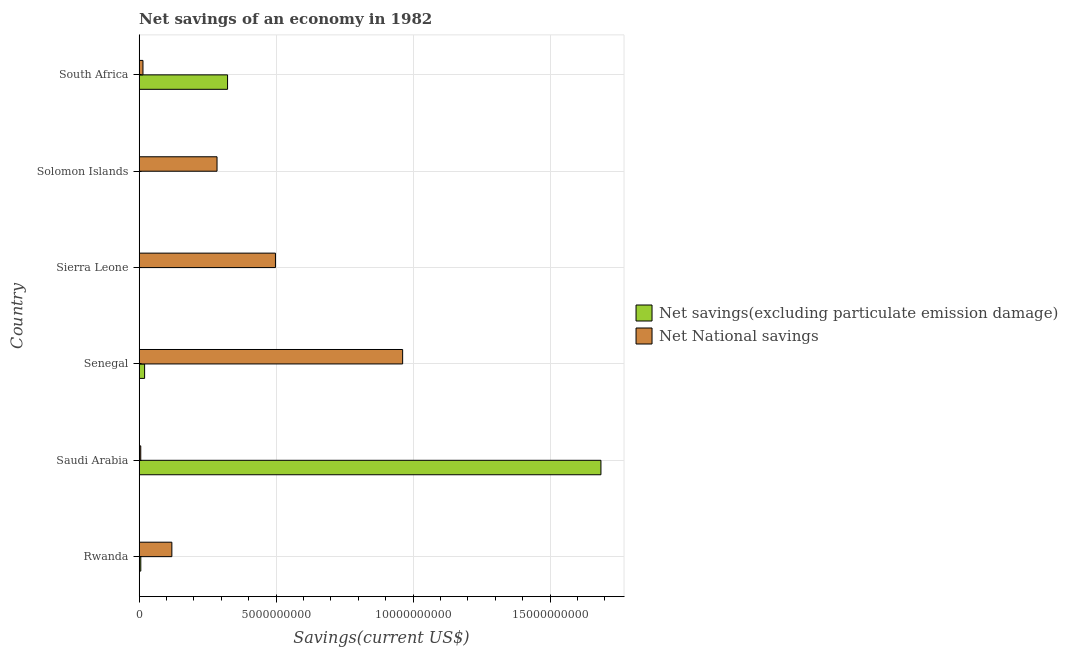Are the number of bars per tick equal to the number of legend labels?
Provide a succinct answer. No. How many bars are there on the 2nd tick from the top?
Give a very brief answer. 1. What is the label of the 3rd group of bars from the top?
Your answer should be very brief. Sierra Leone. In how many cases, is the number of bars for a given country not equal to the number of legend labels?
Make the answer very short. 2. Across all countries, what is the maximum net national savings?
Give a very brief answer. 9.62e+09. Across all countries, what is the minimum net savings(excluding particulate emission damage)?
Your response must be concise. 0. In which country was the net national savings maximum?
Offer a terse response. Senegal. What is the total net national savings in the graph?
Ensure brevity in your answer.  1.88e+1. What is the difference between the net national savings in Rwanda and that in Solomon Islands?
Offer a very short reply. -1.65e+09. What is the difference between the net national savings in Solomon Islands and the net savings(excluding particulate emission damage) in Senegal?
Keep it short and to the point. 2.64e+09. What is the average net savings(excluding particulate emission damage) per country?
Provide a succinct answer. 3.39e+09. What is the difference between the net national savings and net savings(excluding particulate emission damage) in South Africa?
Your response must be concise. -3.09e+09. What is the ratio of the net national savings in Saudi Arabia to that in Senegal?
Your answer should be compact. 0.01. Is the difference between the net savings(excluding particulate emission damage) in Rwanda and Saudi Arabia greater than the difference between the net national savings in Rwanda and Saudi Arabia?
Provide a short and direct response. No. What is the difference between the highest and the second highest net savings(excluding particulate emission damage)?
Ensure brevity in your answer.  1.36e+1. What is the difference between the highest and the lowest net savings(excluding particulate emission damage)?
Your response must be concise. 1.69e+1. In how many countries, is the net savings(excluding particulate emission damage) greater than the average net savings(excluding particulate emission damage) taken over all countries?
Provide a succinct answer. 1. How many bars are there?
Offer a terse response. 10. What is the difference between two consecutive major ticks on the X-axis?
Provide a short and direct response. 5.00e+09. Are the values on the major ticks of X-axis written in scientific E-notation?
Ensure brevity in your answer.  No. Does the graph contain any zero values?
Your response must be concise. Yes. Does the graph contain grids?
Your answer should be compact. Yes. How are the legend labels stacked?
Provide a succinct answer. Vertical. What is the title of the graph?
Offer a terse response. Net savings of an economy in 1982. What is the label or title of the X-axis?
Ensure brevity in your answer.  Savings(current US$). What is the Savings(current US$) of Net savings(excluding particulate emission damage) in Rwanda?
Make the answer very short. 5.99e+07. What is the Savings(current US$) in Net National savings in Rwanda?
Ensure brevity in your answer.  1.19e+09. What is the Savings(current US$) of Net savings(excluding particulate emission damage) in Saudi Arabia?
Your answer should be very brief. 1.69e+1. What is the Savings(current US$) in Net National savings in Saudi Arabia?
Offer a very short reply. 5.80e+07. What is the Savings(current US$) in Net savings(excluding particulate emission damage) in Senegal?
Provide a succinct answer. 1.99e+08. What is the Savings(current US$) of Net National savings in Senegal?
Give a very brief answer. 9.62e+09. What is the Savings(current US$) in Net savings(excluding particulate emission damage) in Sierra Leone?
Your response must be concise. 0. What is the Savings(current US$) in Net National savings in Sierra Leone?
Ensure brevity in your answer.  4.98e+09. What is the Savings(current US$) in Net savings(excluding particulate emission damage) in Solomon Islands?
Provide a succinct answer. 0. What is the Savings(current US$) of Net National savings in Solomon Islands?
Make the answer very short. 2.84e+09. What is the Savings(current US$) in Net savings(excluding particulate emission damage) in South Africa?
Make the answer very short. 3.23e+09. What is the Savings(current US$) of Net National savings in South Africa?
Your answer should be compact. 1.39e+08. Across all countries, what is the maximum Savings(current US$) of Net savings(excluding particulate emission damage)?
Give a very brief answer. 1.69e+1. Across all countries, what is the maximum Savings(current US$) in Net National savings?
Give a very brief answer. 9.62e+09. Across all countries, what is the minimum Savings(current US$) in Net National savings?
Provide a short and direct response. 5.80e+07. What is the total Savings(current US$) in Net savings(excluding particulate emission damage) in the graph?
Provide a short and direct response. 2.03e+1. What is the total Savings(current US$) of Net National savings in the graph?
Offer a terse response. 1.88e+1. What is the difference between the Savings(current US$) of Net savings(excluding particulate emission damage) in Rwanda and that in Saudi Arabia?
Your answer should be compact. -1.68e+1. What is the difference between the Savings(current US$) in Net National savings in Rwanda and that in Saudi Arabia?
Give a very brief answer. 1.14e+09. What is the difference between the Savings(current US$) of Net savings(excluding particulate emission damage) in Rwanda and that in Senegal?
Your answer should be compact. -1.39e+08. What is the difference between the Savings(current US$) of Net National savings in Rwanda and that in Senegal?
Your response must be concise. -8.43e+09. What is the difference between the Savings(current US$) of Net National savings in Rwanda and that in Sierra Leone?
Make the answer very short. -3.78e+09. What is the difference between the Savings(current US$) in Net National savings in Rwanda and that in Solomon Islands?
Offer a very short reply. -1.65e+09. What is the difference between the Savings(current US$) in Net savings(excluding particulate emission damage) in Rwanda and that in South Africa?
Your response must be concise. -3.17e+09. What is the difference between the Savings(current US$) of Net National savings in Rwanda and that in South Africa?
Offer a terse response. 1.05e+09. What is the difference between the Savings(current US$) of Net savings(excluding particulate emission damage) in Saudi Arabia and that in Senegal?
Provide a short and direct response. 1.67e+1. What is the difference between the Savings(current US$) in Net National savings in Saudi Arabia and that in Senegal?
Ensure brevity in your answer.  -9.56e+09. What is the difference between the Savings(current US$) in Net National savings in Saudi Arabia and that in Sierra Leone?
Ensure brevity in your answer.  -4.92e+09. What is the difference between the Savings(current US$) of Net National savings in Saudi Arabia and that in Solomon Islands?
Your answer should be very brief. -2.78e+09. What is the difference between the Savings(current US$) in Net savings(excluding particulate emission damage) in Saudi Arabia and that in South Africa?
Offer a very short reply. 1.36e+1. What is the difference between the Savings(current US$) in Net National savings in Saudi Arabia and that in South Africa?
Your answer should be very brief. -8.08e+07. What is the difference between the Savings(current US$) of Net National savings in Senegal and that in Sierra Leone?
Provide a short and direct response. 4.64e+09. What is the difference between the Savings(current US$) of Net National savings in Senegal and that in Solomon Islands?
Your answer should be very brief. 6.78e+09. What is the difference between the Savings(current US$) of Net savings(excluding particulate emission damage) in Senegal and that in South Africa?
Keep it short and to the point. -3.03e+09. What is the difference between the Savings(current US$) of Net National savings in Senegal and that in South Africa?
Your answer should be very brief. 9.48e+09. What is the difference between the Savings(current US$) of Net National savings in Sierra Leone and that in Solomon Islands?
Your answer should be compact. 2.13e+09. What is the difference between the Savings(current US$) of Net National savings in Sierra Leone and that in South Africa?
Offer a very short reply. 4.84e+09. What is the difference between the Savings(current US$) of Net National savings in Solomon Islands and that in South Africa?
Provide a succinct answer. 2.70e+09. What is the difference between the Savings(current US$) in Net savings(excluding particulate emission damage) in Rwanda and the Savings(current US$) in Net National savings in Saudi Arabia?
Provide a succinct answer. 1.93e+06. What is the difference between the Savings(current US$) of Net savings(excluding particulate emission damage) in Rwanda and the Savings(current US$) of Net National savings in Senegal?
Provide a short and direct response. -9.56e+09. What is the difference between the Savings(current US$) in Net savings(excluding particulate emission damage) in Rwanda and the Savings(current US$) in Net National savings in Sierra Leone?
Offer a very short reply. -4.92e+09. What is the difference between the Savings(current US$) in Net savings(excluding particulate emission damage) in Rwanda and the Savings(current US$) in Net National savings in Solomon Islands?
Provide a short and direct response. -2.78e+09. What is the difference between the Savings(current US$) of Net savings(excluding particulate emission damage) in Rwanda and the Savings(current US$) of Net National savings in South Africa?
Provide a short and direct response. -7.88e+07. What is the difference between the Savings(current US$) of Net savings(excluding particulate emission damage) in Saudi Arabia and the Savings(current US$) of Net National savings in Senegal?
Offer a very short reply. 7.24e+09. What is the difference between the Savings(current US$) of Net savings(excluding particulate emission damage) in Saudi Arabia and the Savings(current US$) of Net National savings in Sierra Leone?
Offer a terse response. 1.19e+1. What is the difference between the Savings(current US$) of Net savings(excluding particulate emission damage) in Saudi Arabia and the Savings(current US$) of Net National savings in Solomon Islands?
Give a very brief answer. 1.40e+1. What is the difference between the Savings(current US$) in Net savings(excluding particulate emission damage) in Saudi Arabia and the Savings(current US$) in Net National savings in South Africa?
Give a very brief answer. 1.67e+1. What is the difference between the Savings(current US$) in Net savings(excluding particulate emission damage) in Senegal and the Savings(current US$) in Net National savings in Sierra Leone?
Your response must be concise. -4.78e+09. What is the difference between the Savings(current US$) of Net savings(excluding particulate emission damage) in Senegal and the Savings(current US$) of Net National savings in Solomon Islands?
Provide a short and direct response. -2.64e+09. What is the difference between the Savings(current US$) of Net savings(excluding particulate emission damage) in Senegal and the Savings(current US$) of Net National savings in South Africa?
Provide a short and direct response. 6.02e+07. What is the average Savings(current US$) of Net savings(excluding particulate emission damage) per country?
Offer a terse response. 3.39e+09. What is the average Savings(current US$) of Net National savings per country?
Keep it short and to the point. 3.14e+09. What is the difference between the Savings(current US$) in Net savings(excluding particulate emission damage) and Savings(current US$) in Net National savings in Rwanda?
Your answer should be very brief. -1.13e+09. What is the difference between the Savings(current US$) of Net savings(excluding particulate emission damage) and Savings(current US$) of Net National savings in Saudi Arabia?
Provide a short and direct response. 1.68e+1. What is the difference between the Savings(current US$) in Net savings(excluding particulate emission damage) and Savings(current US$) in Net National savings in Senegal?
Offer a terse response. -9.42e+09. What is the difference between the Savings(current US$) of Net savings(excluding particulate emission damage) and Savings(current US$) of Net National savings in South Africa?
Make the answer very short. 3.09e+09. What is the ratio of the Savings(current US$) in Net savings(excluding particulate emission damage) in Rwanda to that in Saudi Arabia?
Offer a terse response. 0. What is the ratio of the Savings(current US$) of Net National savings in Rwanda to that in Saudi Arabia?
Make the answer very short. 20.58. What is the ratio of the Savings(current US$) of Net savings(excluding particulate emission damage) in Rwanda to that in Senegal?
Your response must be concise. 0.3. What is the ratio of the Savings(current US$) in Net National savings in Rwanda to that in Senegal?
Give a very brief answer. 0.12. What is the ratio of the Savings(current US$) in Net National savings in Rwanda to that in Sierra Leone?
Provide a succinct answer. 0.24. What is the ratio of the Savings(current US$) of Net National savings in Rwanda to that in Solomon Islands?
Keep it short and to the point. 0.42. What is the ratio of the Savings(current US$) of Net savings(excluding particulate emission damage) in Rwanda to that in South Africa?
Your answer should be compact. 0.02. What is the ratio of the Savings(current US$) in Net National savings in Rwanda to that in South Africa?
Keep it short and to the point. 8.6. What is the ratio of the Savings(current US$) in Net savings(excluding particulate emission damage) in Saudi Arabia to that in Senegal?
Keep it short and to the point. 84.72. What is the ratio of the Savings(current US$) in Net National savings in Saudi Arabia to that in Senegal?
Keep it short and to the point. 0.01. What is the ratio of the Savings(current US$) of Net National savings in Saudi Arabia to that in Sierra Leone?
Give a very brief answer. 0.01. What is the ratio of the Savings(current US$) of Net National savings in Saudi Arabia to that in Solomon Islands?
Offer a very short reply. 0.02. What is the ratio of the Savings(current US$) in Net savings(excluding particulate emission damage) in Saudi Arabia to that in South Africa?
Offer a very short reply. 5.22. What is the ratio of the Savings(current US$) in Net National savings in Saudi Arabia to that in South Africa?
Ensure brevity in your answer.  0.42. What is the ratio of the Savings(current US$) of Net National savings in Senegal to that in Sierra Leone?
Make the answer very short. 1.93. What is the ratio of the Savings(current US$) in Net National savings in Senegal to that in Solomon Islands?
Your answer should be very brief. 3.38. What is the ratio of the Savings(current US$) in Net savings(excluding particulate emission damage) in Senegal to that in South Africa?
Keep it short and to the point. 0.06. What is the ratio of the Savings(current US$) in Net National savings in Senegal to that in South Africa?
Provide a succinct answer. 69.33. What is the ratio of the Savings(current US$) of Net National savings in Sierra Leone to that in Solomon Islands?
Offer a very short reply. 1.75. What is the ratio of the Savings(current US$) of Net National savings in Sierra Leone to that in South Africa?
Offer a terse response. 35.86. What is the ratio of the Savings(current US$) in Net National savings in Solomon Islands to that in South Africa?
Your response must be concise. 20.49. What is the difference between the highest and the second highest Savings(current US$) of Net savings(excluding particulate emission damage)?
Your response must be concise. 1.36e+1. What is the difference between the highest and the second highest Savings(current US$) in Net National savings?
Keep it short and to the point. 4.64e+09. What is the difference between the highest and the lowest Savings(current US$) of Net savings(excluding particulate emission damage)?
Your answer should be very brief. 1.69e+1. What is the difference between the highest and the lowest Savings(current US$) in Net National savings?
Make the answer very short. 9.56e+09. 